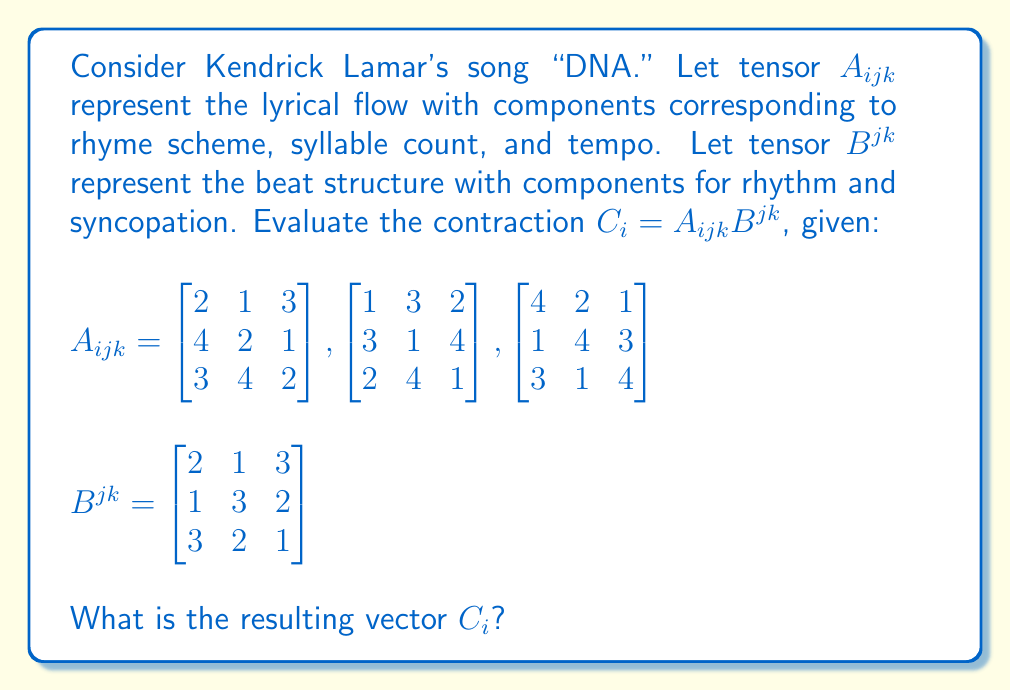Provide a solution to this math problem. To evaluate the contraction $C_i = A_{ijk}B^{jk}$, we need to sum over the repeated indices $j$ and $k$. Let's break it down step-by-step:

1) The contraction can be written as:
   $$C_i = \sum_{j=1}^3 \sum_{k=1}^3 A_{ijk}B^{jk}$$

2) We'll calculate each component of $C_i$ separately:

   For $i = 1$:
   $$C_1 = \sum_{j=1}^3 \sum_{k=1}^3 A_{1jk}B^{jk}$$
   $= (2 \cdot 2 + 1 \cdot 1 + 3 \cdot 3) + (1 \cdot 1 + 3 \cdot 3 + 2 \cdot 2) + (3 \cdot 3 + 1 \cdot 2 + 2 \cdot 1)$
   $= (4 + 1 + 9) + (1 + 9 + 4) + (9 + 2 + 2)$
   $= 14 + 14 + 13 = 41$

   For $i = 2$:
   $$C_2 = \sum_{j=1}^3 \sum_{k=1}^3 A_{2jk}B^{jk}$$
   $= (4 \cdot 2 + 2 \cdot 1 + 1 \cdot 3) + (3 \cdot 1 + 1 \cdot 3 + 4 \cdot 2) + (1 \cdot 3 + 4 \cdot 2 + 3 \cdot 1)$
   $= (8 + 2 + 3) + (3 + 3 + 8) + (3 + 8 + 3)$
   $= 13 + 14 + 14 = 41$

   For $i = 3$:
   $$C_3 = \sum_{j=1}^3 \sum_{k=1}^3 A_{3jk}B^{jk}$$
   $= (3 \cdot 2 + 4 \cdot 1 + 2 \cdot 3) + (2 \cdot 1 + 4 \cdot 3 + 1 \cdot 2) + (3 \cdot 3 + 1 \cdot 2 + 4 \cdot 1)$
   $= (6 + 4 + 6) + (2 + 12 + 2) + (9 + 2 + 4)$
   $= 16 + 16 + 15 = 47$

3) Therefore, the resulting vector $C_i$ is:
   $$C_i = \begin{bmatrix} 41 \\ 41 \\ 47 \end{bmatrix}$$
Answer: $C_i = \begin{bmatrix} 41 \\ 41 \\ 47 \end{bmatrix}$ 